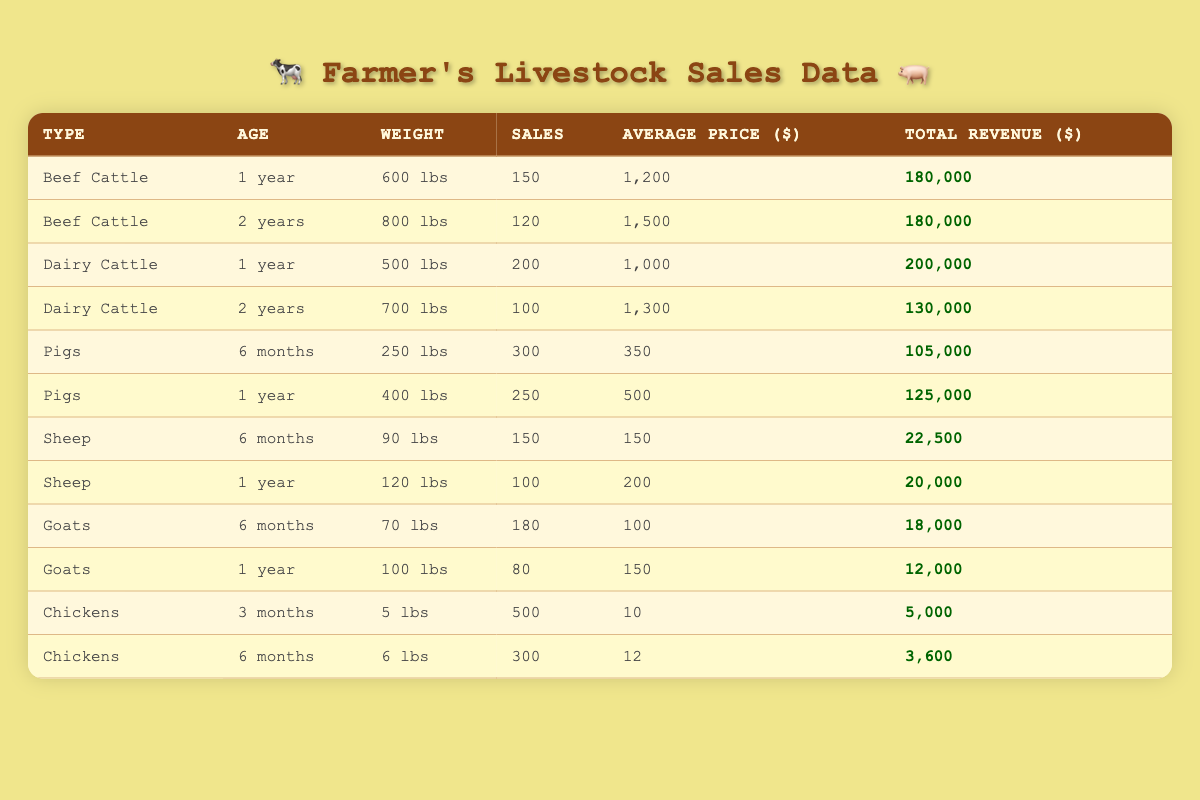What is the total revenue from Beef Cattle sales? To find the total revenue from Beef Cattle sales, we add the total revenues for both age groups: 180,000 (1 year) + 180,000 (2 years) = 360,000.
Answer: 360,000 Which type of livestock has the highest average price? By comparing the average prices: Beef Cattle (1,200 and 1,500), Dairy Cattle (1,000 and 1,300), Pigs (350 and 500), Sheep (150 and 200), Goats (100 and 150), and Chickens (10 and 12); the highest average price is 1,500 for Beef Cattle.
Answer: Beef Cattle How many Pigs were sold in total? The total number of Pigs sold is the sum of sales from both age groups: 300 (6 months) + 250 (1 year) = 550.
Answer: 550 What is the average weight of Dairy Cattle sold? The average weight is calculated as follows: (500 lbs + 700 lbs) / 2 = 600 lbs.
Answer: 600 lbs Is there any livestock type that generated total revenue less than 25,000? Checking the total revenues, Sheep (22,500), Goats (18,000), and Chickens (5,000) all generated revenues less than 25,000.
Answer: Yes How much total revenue did Chickens generate compared to Sheep? Chickens generated 5,000 (3 months) + 3,600 (6 months) = 8,600. Sheep generated 22,500 (6 months) + 20,000 (1 year) = 42,500. So, Sheep generated more revenue, specifically 42,500 - 8,600 = 33,900 more.
Answer: Chickens generated 8,600 less revenue than Sheep Which livestock type had the highest number of sales? The highest sales occurred with Pigs (300 + 250 = 550). Comparing with other types, Pigs have the highest sales amount.
Answer: Pigs had the highest sales What percentage of total Dairy Cattle revenue comes from 1-year-olds? The total Dairy Cattle revenue is 200,000 (1 year) + 130,000 (2 years) = 330,000. The revenue from 1-year-olds is 200,000. The percentage is (200,000 / 330,000) * 100 ≈ 60.61%.
Answer: Approximately 60.61% How many more Beef Cattle were sold compared to Goats? Total Beef Cattle sold is 150 (1 year) + 120 (2 years) = 270. Total Goats sold is 180 (6 months) + 80 (1 year) = 260. Thus, Beef Cattle sold 270 - 260 = 10 more.
Answer: 10 more Beef Cattle were sold 